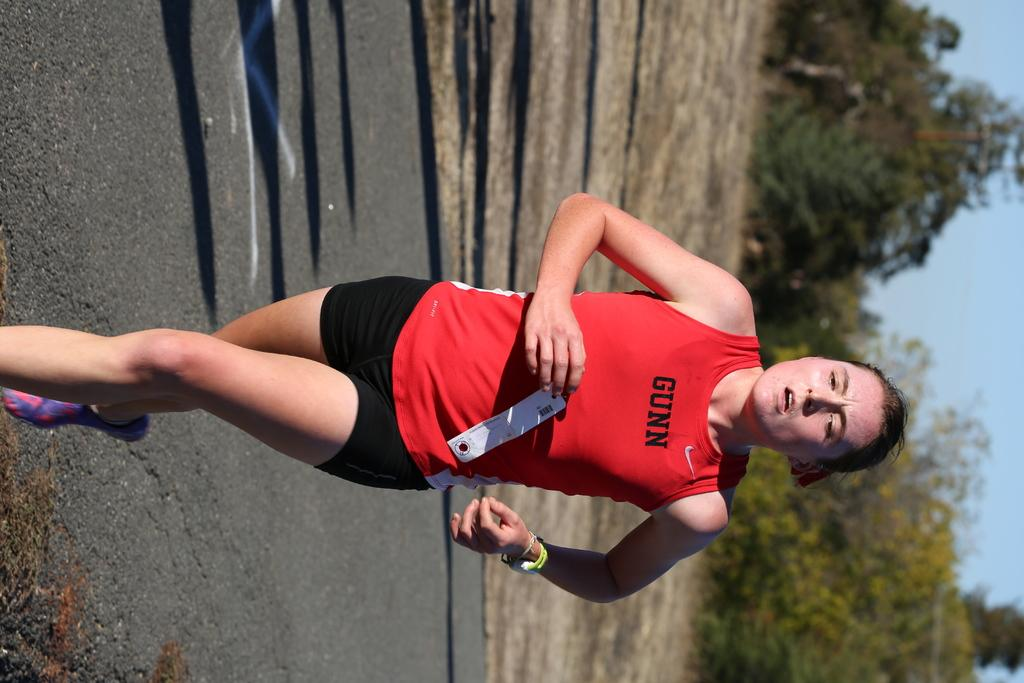<image>
Share a concise interpretation of the image provided. A runner wearing a shirt which reads GUNN breathes hard as she runs. 